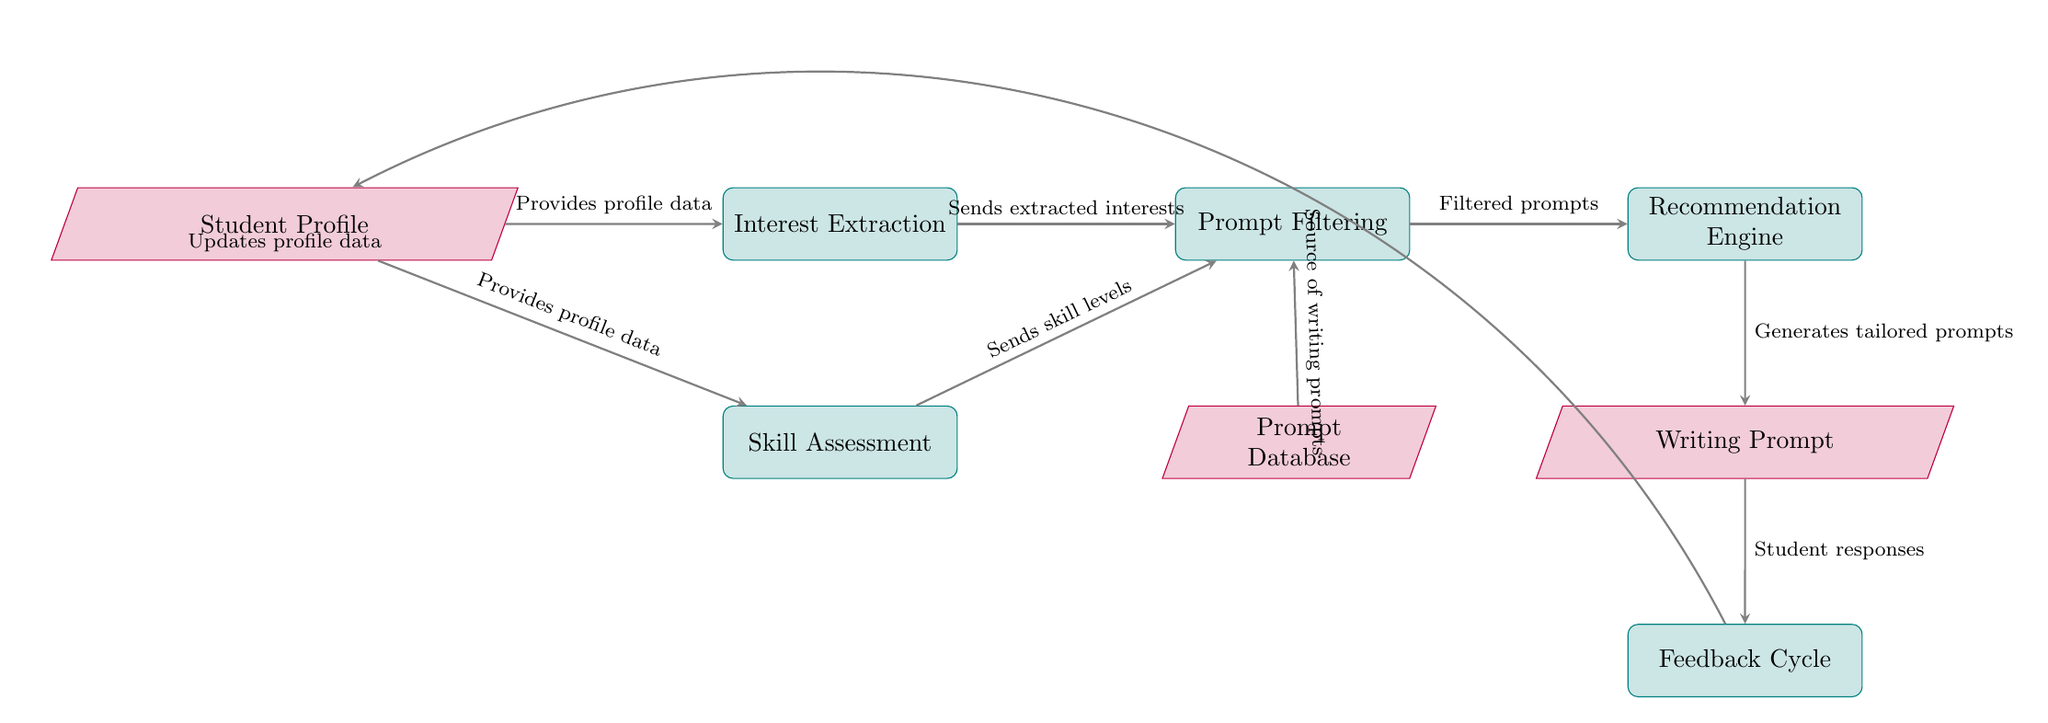What is the main function of the "Recommendation Engine"? The "Recommendation Engine" node follows the "Prompt Filtering" process and receives filtered prompts to generate tailored writing prompts based on student interests and skill levels.
Answer: Generates tailored prompts How many process nodes are in the diagram? The diagram contains six process nodes: Interest Extraction, Skill Assessment, Prompt Filtering, Recommendation Engine, Feedback Cycle, and one additional node is input for the Student Profile.
Answer: six Which node provides profile data to "Interest Extraction"? According to the diagram, the "Student Profile" node provides profile data to the "Interest Extraction" process.
Answer: Student Profile What type of data does the "Prompt Database" supply to "Prompt Filtering"? The "Prompt Database" node supplies writing prompts as a source of filtered prompts to the "Prompt Filtering" process.
Answer: writing prompts How does the "Feedback Cycle" interact with the "Student Profile"? The "Feedback Cycle" receives student responses from the generated writing prompt and sends updated profile data back to the "Student Profile" node, connecting the student experience back into the recommendation process.
Answer: Updates profile data What information sent from "Skill Assessment" is used in the "Prompt Filtering"? The "Skill Assessment" process sends skill levels to the "Prompt Filtering" node, which utilizes this information alongside extracted interests to filter the prompts effectively.
Answer: Sends skill levels What are the outputs from the "Recommendation Engine"? The "Recommendation Engine" outputs tailored writing prompts that are specifically suited to the interests and skill levels of the student based on the filtered data it receives.
Answer: Writing Prompt Which two nodes are connected directly without any other node in between? The "Prompt Filtering" process connects directly to the "Recommendation Engine", receiving filtered prompts without other intervening nodes, establishing a direct flow in the diagram.
Answer: Prompt Filtering and Recommendation Engine 